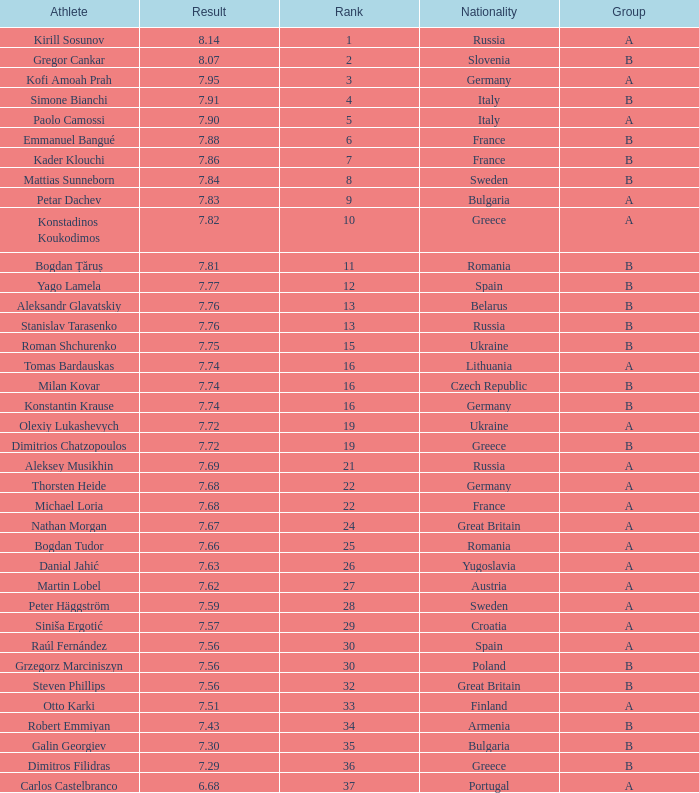Which athlete's rank is more than 15 when the result is less than 7.68, the group is b, and the nationality listed is Great Britain? Steven Phillips. 